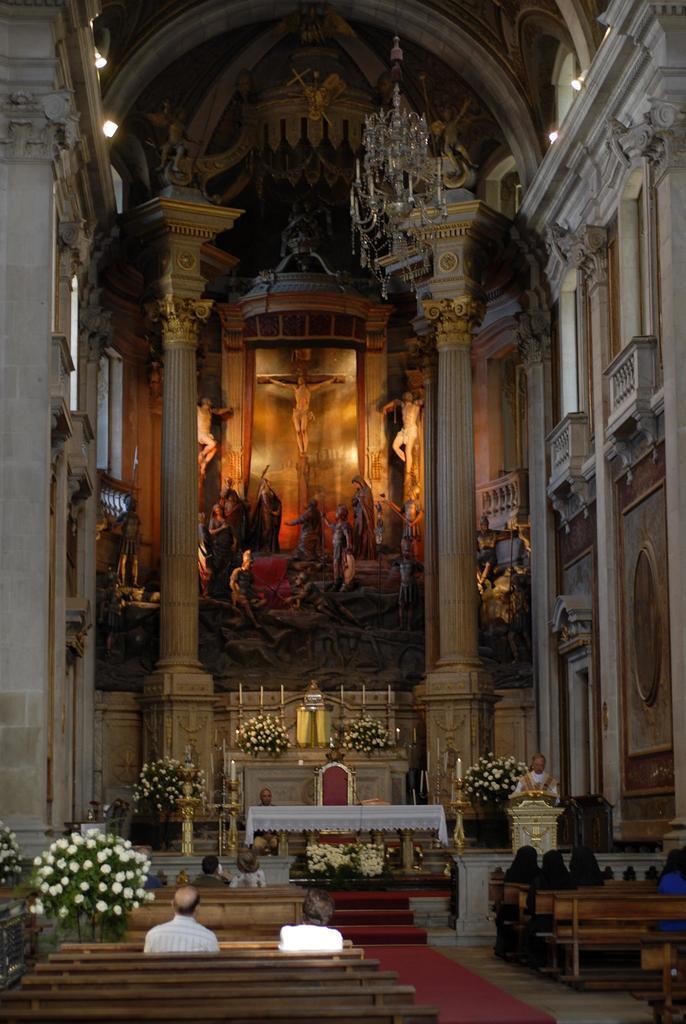In one or two sentences, can you explain what this image depicts? This is an inside view of a church. At the bottom I can see few people are sitting on the benches. In the front there is a table which is covered with a cloth and also I can see a chair. Around these I can see few flower plants. At the top there are some pillars and I can see few statues. At the top of the image there is a chandelier which is hanging. 